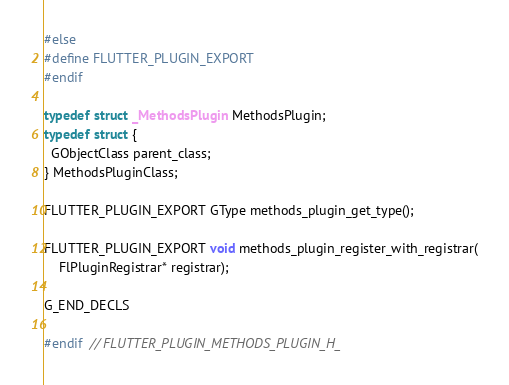<code> <loc_0><loc_0><loc_500><loc_500><_C_>#else
#define FLUTTER_PLUGIN_EXPORT
#endif

typedef struct _MethodsPlugin MethodsPlugin;
typedef struct {
  GObjectClass parent_class;
} MethodsPluginClass;

FLUTTER_PLUGIN_EXPORT GType methods_plugin_get_type();

FLUTTER_PLUGIN_EXPORT void methods_plugin_register_with_registrar(
    FlPluginRegistrar* registrar);

G_END_DECLS

#endif  // FLUTTER_PLUGIN_METHODS_PLUGIN_H_
</code> 